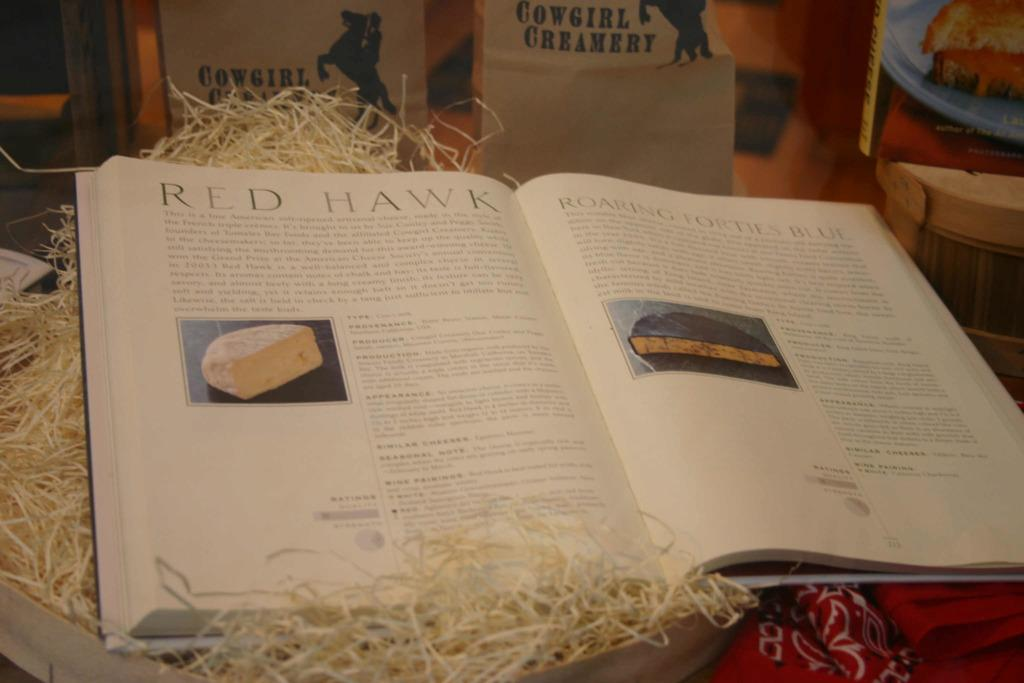Provide a one-sentence caption for the provided image. an open book with the page titled 'Red Hawk'. 